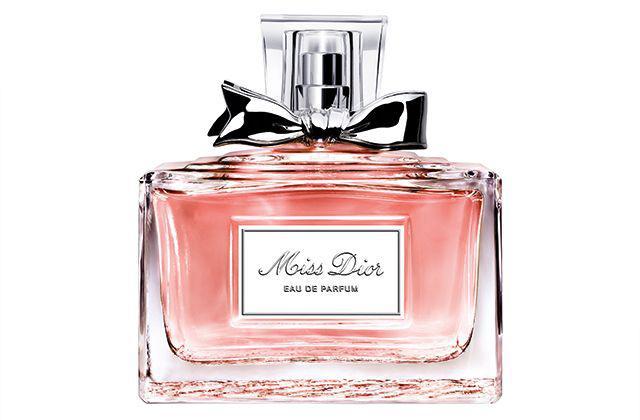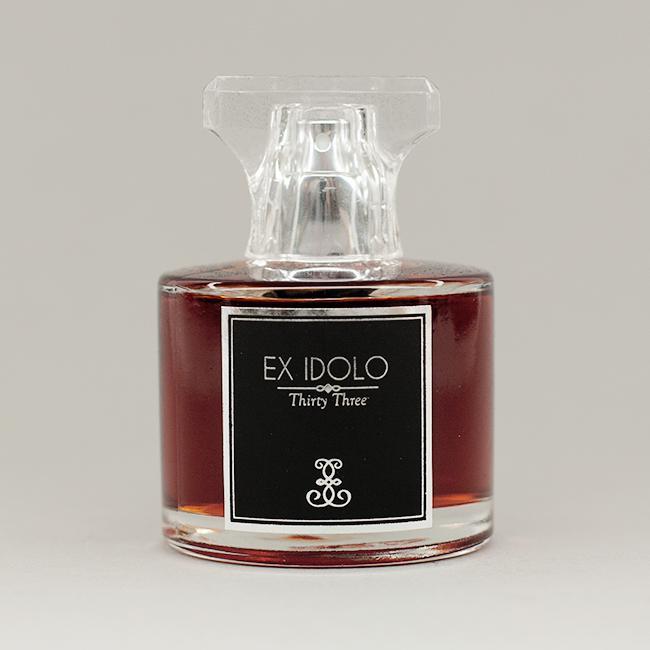The first image is the image on the left, the second image is the image on the right. For the images displayed, is the sentence "One image shows a fragrance bottle of brown liquid with a black label and a glass-look cap shaped somewhat like a T." factually correct? Answer yes or no. Yes. 